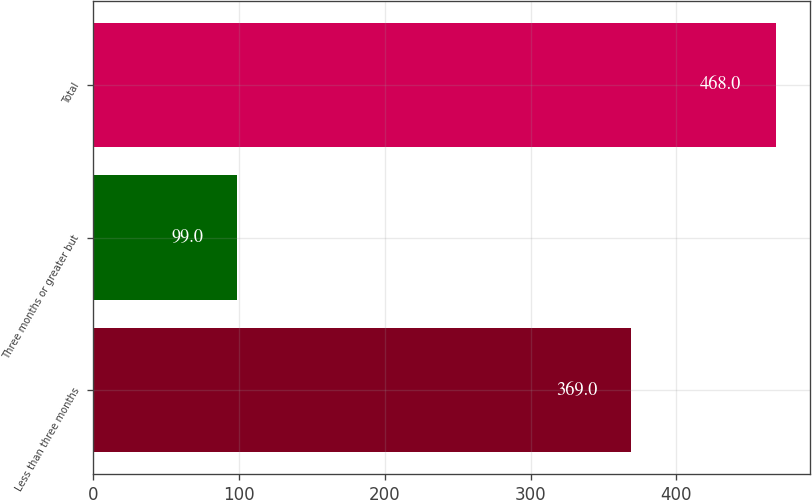Convert chart. <chart><loc_0><loc_0><loc_500><loc_500><bar_chart><fcel>Less than three months<fcel>Three months or greater but<fcel>Total<nl><fcel>369<fcel>99<fcel>468<nl></chart> 